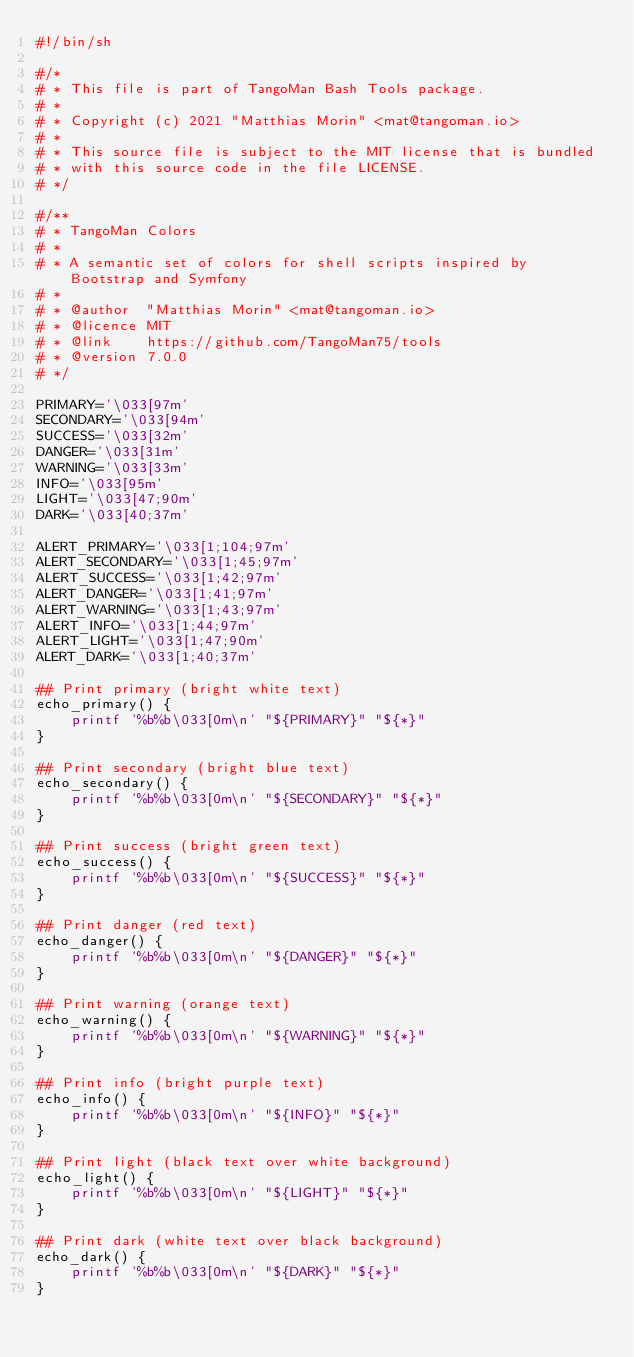Convert code to text. <code><loc_0><loc_0><loc_500><loc_500><_Bash_>#!/bin/sh

#/*
# * This file is part of TangoMan Bash Tools package.
# *
# * Copyright (c) 2021 "Matthias Morin" <mat@tangoman.io>
# *
# * This source file is subject to the MIT license that is bundled
# * with this source code in the file LICENSE.
# */

#/**
# * TangoMan Colors
# *
# * A semantic set of colors for shell scripts inspired by Bootstrap and Symfony
# *
# * @author  "Matthias Morin" <mat@tangoman.io>
# * @licence MIT
# * @link    https://github.com/TangoMan75/tools
# * @version 7.0.0
# */

PRIMARY='\033[97m'
SECONDARY='\033[94m'
SUCCESS='\033[32m'
DANGER='\033[31m'
WARNING='\033[33m'
INFO='\033[95m'
LIGHT='\033[47;90m'
DARK='\033[40;37m'

ALERT_PRIMARY='\033[1;104;97m'
ALERT_SECONDARY='\033[1;45;97m'
ALERT_SUCCESS='\033[1;42;97m'
ALERT_DANGER='\033[1;41;97m'
ALERT_WARNING='\033[1;43;97m'
ALERT_INFO='\033[1;44;97m'
ALERT_LIGHT='\033[1;47;90m'
ALERT_DARK='\033[1;40;37m'

## Print primary (bright white text)
echo_primary() {
    printf '%b%b\033[0m\n' "${PRIMARY}" "${*}"
}

## Print secondary (bright blue text)
echo_secondary() {
    printf '%b%b\033[0m\n' "${SECONDARY}" "${*}"
}

## Print success (bright green text)
echo_success() {
    printf '%b%b\033[0m\n' "${SUCCESS}" "${*}"
}

## Print danger (red text)
echo_danger() {
    printf '%b%b\033[0m\n' "${DANGER}" "${*}"
}

## Print warning (orange text)
echo_warning() {
    printf '%b%b\033[0m\n' "${WARNING}" "${*}"
}

## Print info (bright purple text)
echo_info() {
    printf '%b%b\033[0m\n' "${INFO}" "${*}"
}

## Print light (black text over white background)
echo_light() {
    printf '%b%b\033[0m\n' "${LIGHT}" "${*}"
}

## Print dark (white text over black background)
echo_dark() {
    printf '%b%b\033[0m\n' "${DARK}" "${*}"
}
</code> 